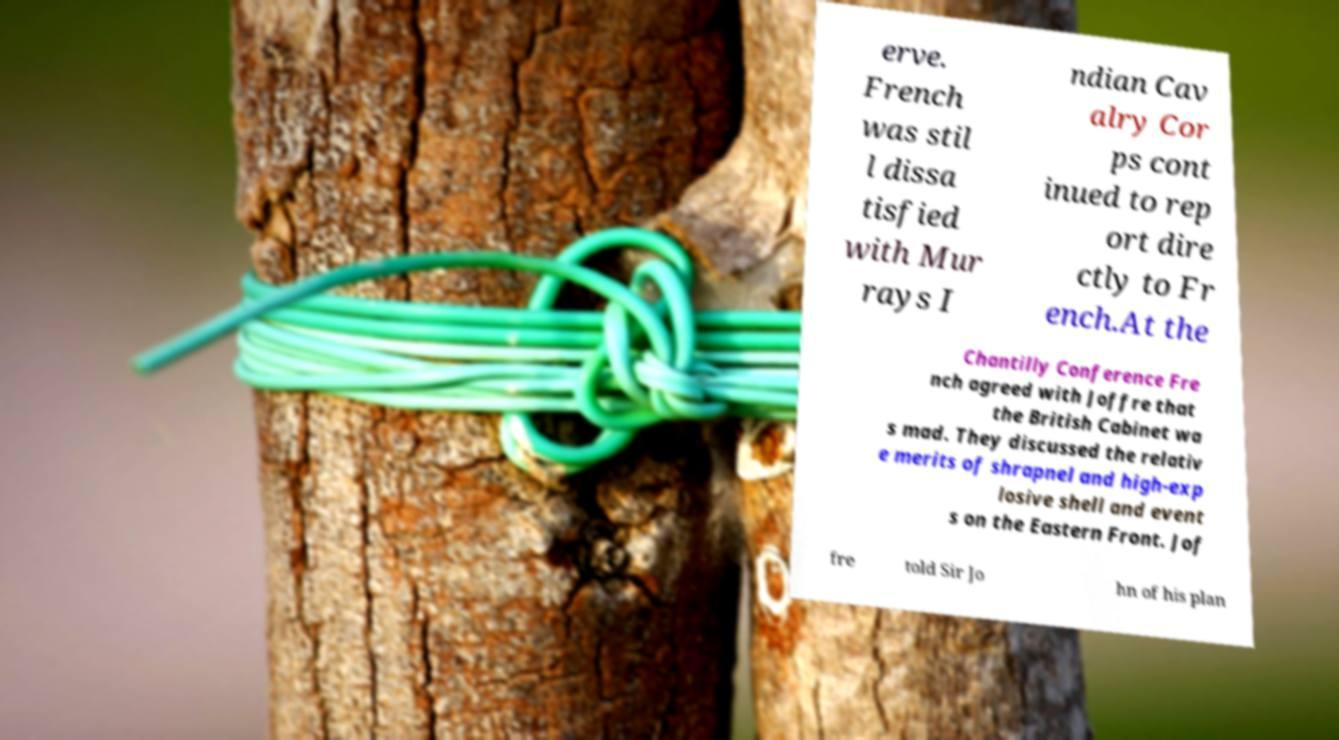Can you accurately transcribe the text from the provided image for me? erve. French was stil l dissa tisfied with Mur rays I ndian Cav alry Cor ps cont inued to rep ort dire ctly to Fr ench.At the Chantilly Conference Fre nch agreed with Joffre that the British Cabinet wa s mad. They discussed the relativ e merits of shrapnel and high-exp losive shell and event s on the Eastern Front. Jof fre told Sir Jo hn of his plan 